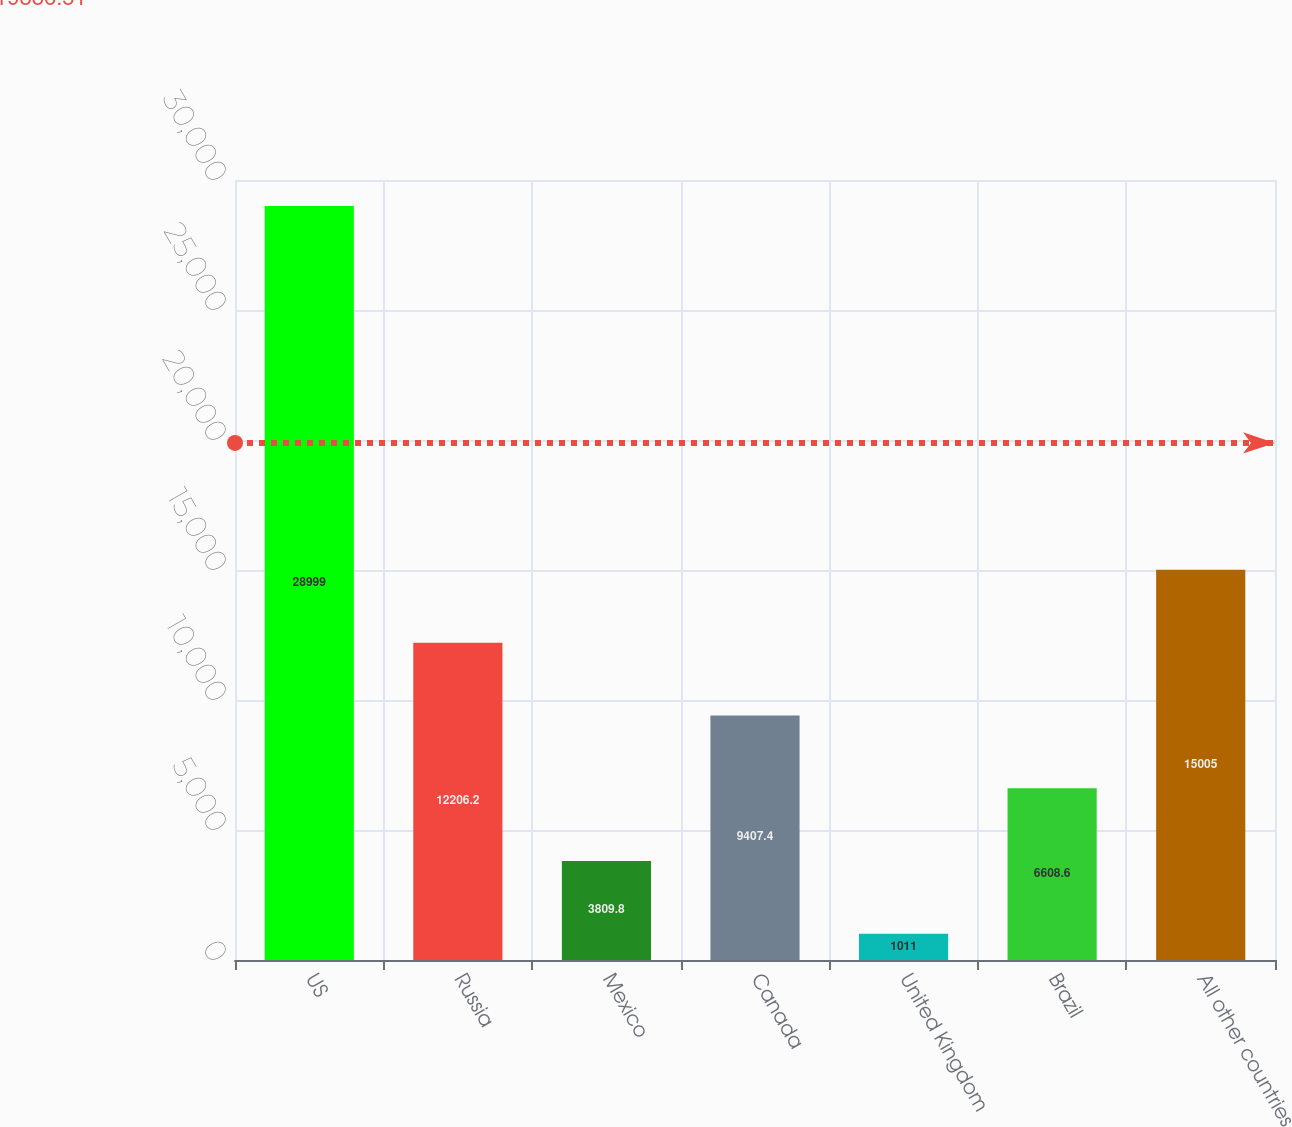Convert chart. <chart><loc_0><loc_0><loc_500><loc_500><bar_chart><fcel>US<fcel>Russia<fcel>Mexico<fcel>Canada<fcel>United Kingdom<fcel>Brazil<fcel>All other countries<nl><fcel>28999<fcel>12206.2<fcel>3809.8<fcel>9407.4<fcel>1011<fcel>6608.6<fcel>15005<nl></chart> 